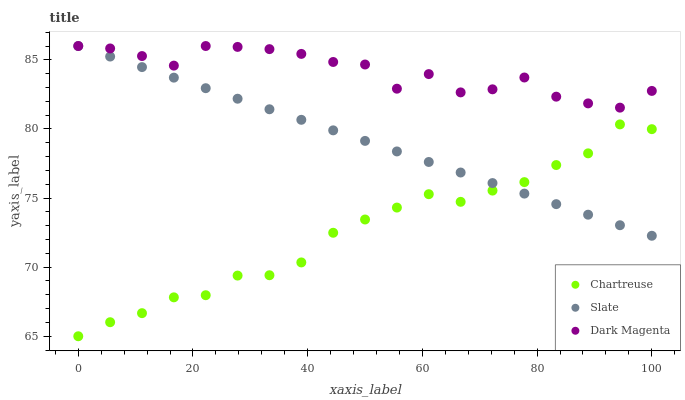Does Chartreuse have the minimum area under the curve?
Answer yes or no. Yes. Does Dark Magenta have the maximum area under the curve?
Answer yes or no. Yes. Does Slate have the minimum area under the curve?
Answer yes or no. No. Does Slate have the maximum area under the curve?
Answer yes or no. No. Is Slate the smoothest?
Answer yes or no. Yes. Is Dark Magenta the roughest?
Answer yes or no. Yes. Is Dark Magenta the smoothest?
Answer yes or no. No. Is Slate the roughest?
Answer yes or no. No. Does Chartreuse have the lowest value?
Answer yes or no. Yes. Does Slate have the lowest value?
Answer yes or no. No. Does Dark Magenta have the highest value?
Answer yes or no. Yes. Is Chartreuse less than Dark Magenta?
Answer yes or no. Yes. Is Dark Magenta greater than Chartreuse?
Answer yes or no. Yes. Does Slate intersect Chartreuse?
Answer yes or no. Yes. Is Slate less than Chartreuse?
Answer yes or no. No. Is Slate greater than Chartreuse?
Answer yes or no. No. Does Chartreuse intersect Dark Magenta?
Answer yes or no. No. 